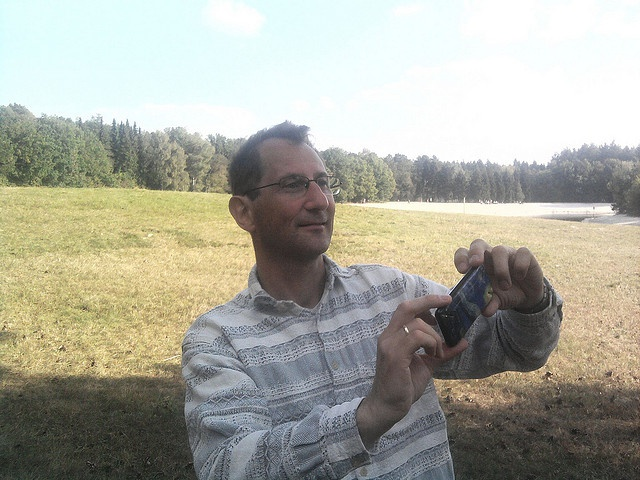Describe the objects in this image and their specific colors. I can see people in lightblue, gray, darkgray, and black tones and cell phone in lightblue, black, and gray tones in this image. 